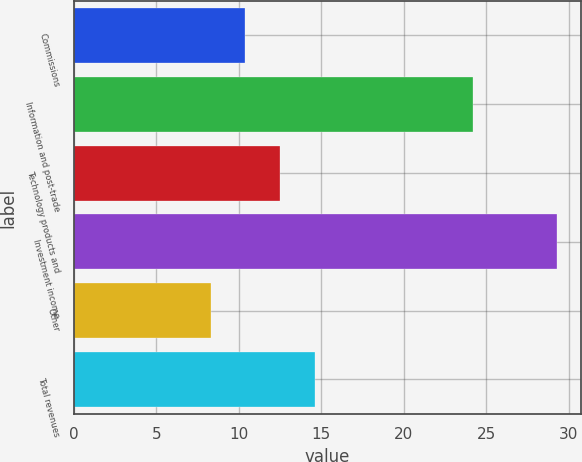Convert chart to OTSL. <chart><loc_0><loc_0><loc_500><loc_500><bar_chart><fcel>Commissions<fcel>Information and post-trade<fcel>Technology products and<fcel>Investment income<fcel>Other<fcel>Total revenues<nl><fcel>10.4<fcel>24.2<fcel>12.5<fcel>29.3<fcel>8.3<fcel>14.6<nl></chart> 